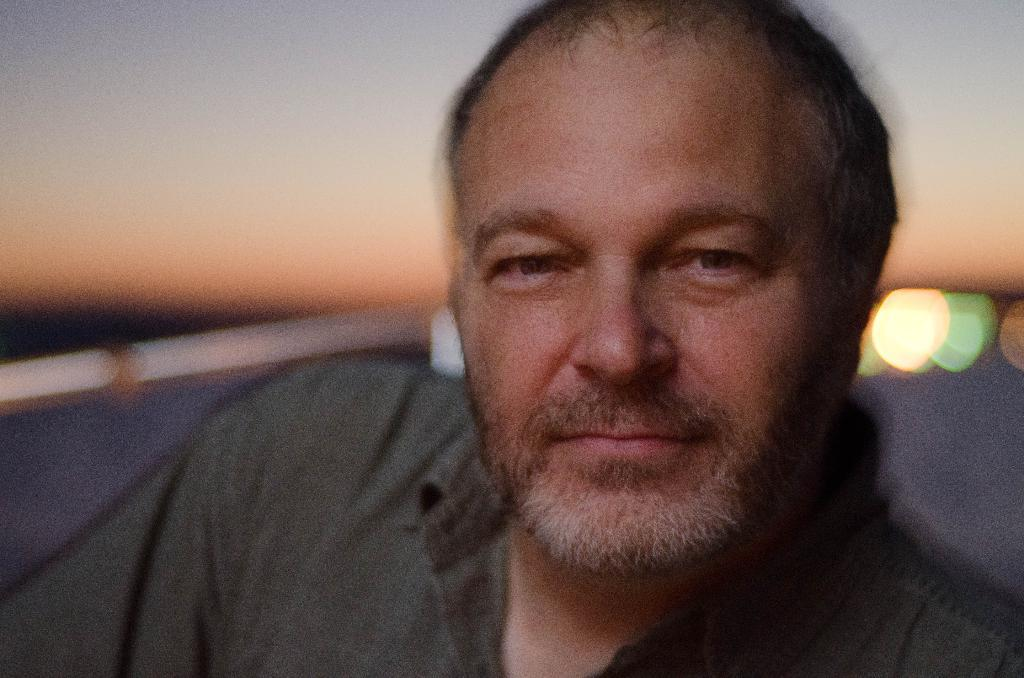Who or what is the main subject in the center of the image? There is a person in the center of the image. What can be seen in the distance behind the person? The sky is visible in the background of the image. Are there any additional elements in the background? Yes, there are lights in the background of the image. How would you describe the appearance of the background? The background appears blurred. What type of competition is taking place in the image? There is no competition present in the image; it features a person with a blurred background. 